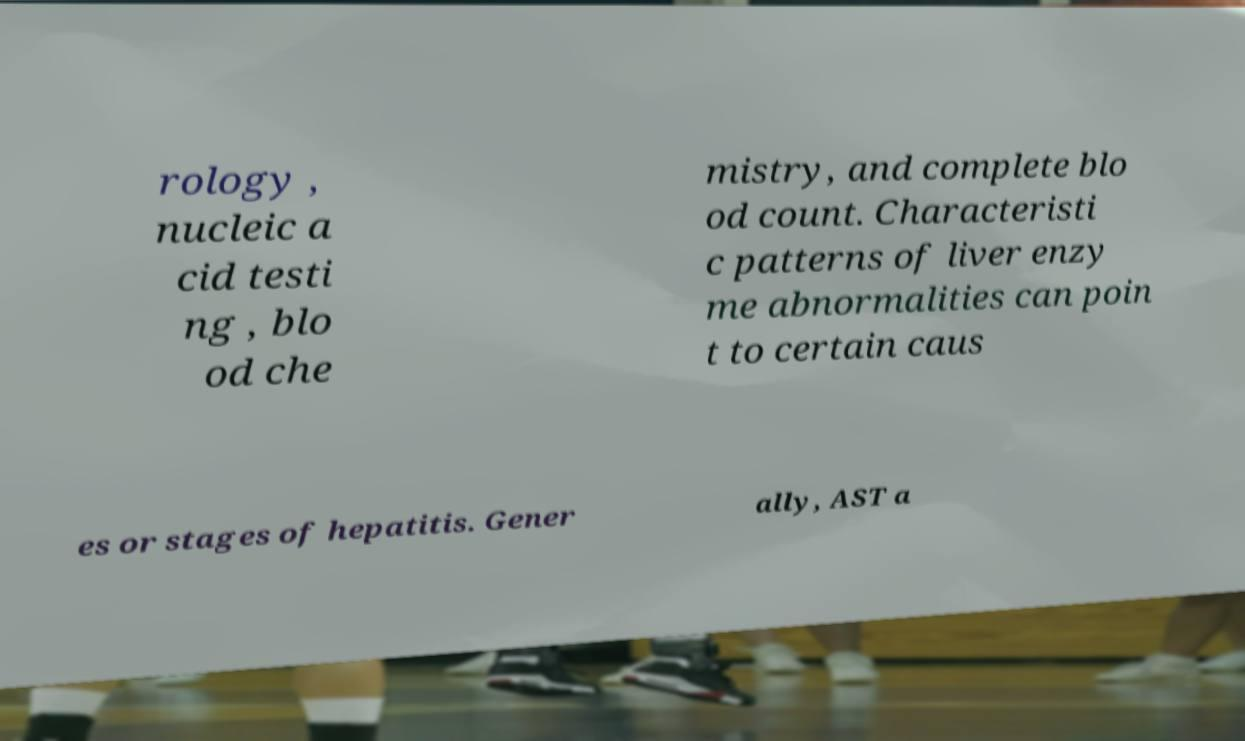Could you extract and type out the text from this image? rology , nucleic a cid testi ng , blo od che mistry, and complete blo od count. Characteristi c patterns of liver enzy me abnormalities can poin t to certain caus es or stages of hepatitis. Gener ally, AST a 